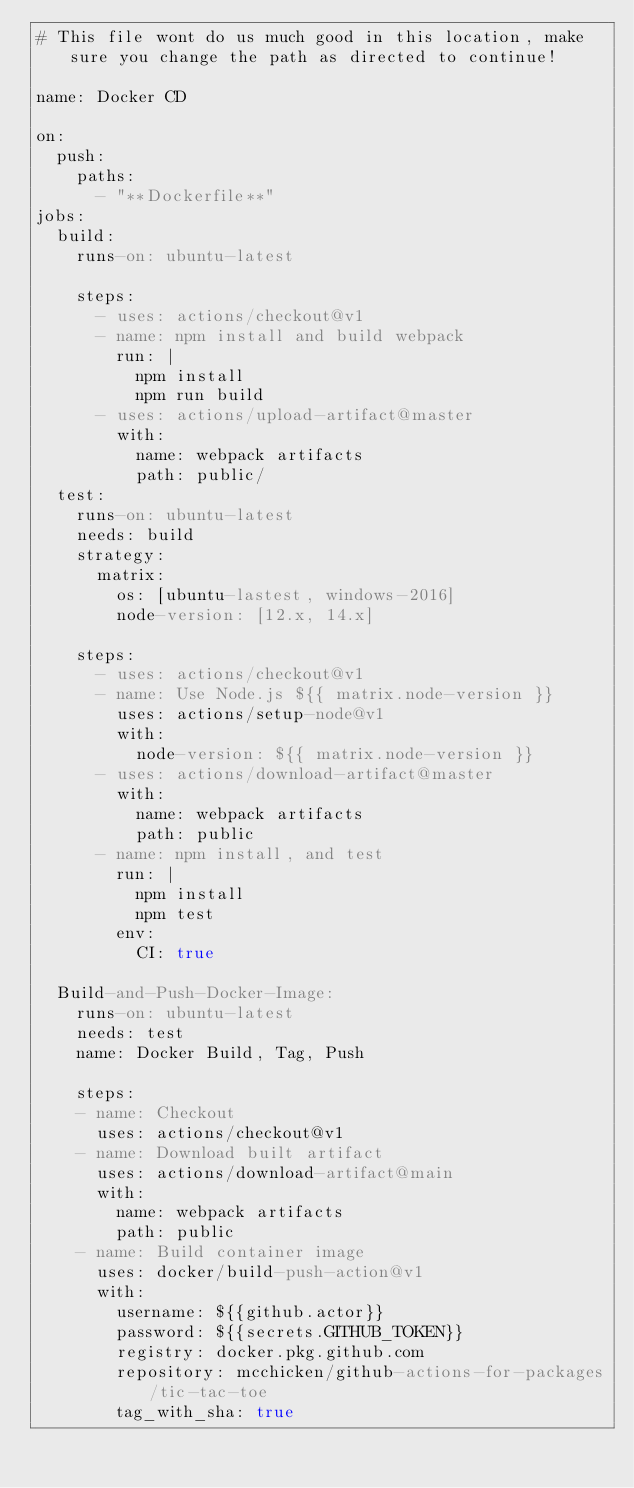<code> <loc_0><loc_0><loc_500><loc_500><_YAML_># This file wont do us much good in this location, make sure you change the path as directed to continue!

name: Docker CD

on:
  push:
    paths:
      - "**Dockerfile**"
jobs:
  build:
    runs-on: ubuntu-latest

    steps:
      - uses: actions/checkout@v1
      - name: npm install and build webpack
        run: |
          npm install
          npm run build
      - uses: actions/upload-artifact@master
        with:
          name: webpack artifacts
          path: public/
  test:
    runs-on: ubuntu-latest
    needs: build
    strategy:
      matrix:
        os: [ubuntu-lastest, windows-2016]
        node-version: [12.x, 14.x]

    steps:
      - uses: actions/checkout@v1
      - name: Use Node.js ${{ matrix.node-version }}
        uses: actions/setup-node@v1
        with:
          node-version: ${{ matrix.node-version }}
      - uses: actions/download-artifact@master
        with:
          name: webpack artifacts
          path: public
      - name: npm install, and test
        run: |
          npm install
          npm test
        env:
          CI: true

  Build-and-Push-Docker-Image:
    runs-on: ubuntu-latest
    needs: test
    name: Docker Build, Tag, Push

    steps:
    - name: Checkout
      uses: actions/checkout@v1
    - name: Download built artifact
      uses: actions/download-artifact@main
      with:
        name: webpack artifacts
        path: public
    - name: Build container image
      uses: docker/build-push-action@v1
      with:
        username: ${{github.actor}}
        password: ${{secrets.GITHUB_TOKEN}}
        registry: docker.pkg.github.com
        repository: mcchicken/github-actions-for-packages/tic-tac-toe
        tag_with_sha: true

</code> 